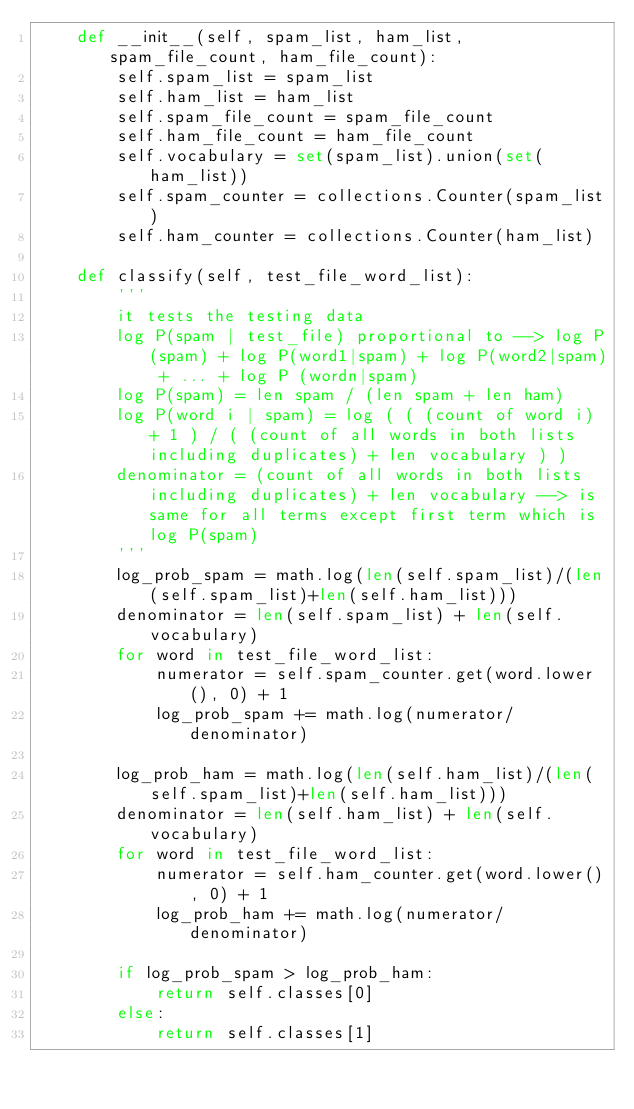Convert code to text. <code><loc_0><loc_0><loc_500><loc_500><_Python_>    def __init__(self, spam_list, ham_list, spam_file_count, ham_file_count):
        self.spam_list = spam_list
        self.ham_list = ham_list
        self.spam_file_count = spam_file_count
        self.ham_file_count = ham_file_count
        self.vocabulary = set(spam_list).union(set(ham_list))
        self.spam_counter = collections.Counter(spam_list)
        self.ham_counter = collections.Counter(ham_list)

    def classify(self, test_file_word_list):
        '''
        it tests the testing data
        log P(spam | test_file) proportional to --> log P(spam) + log P(word1|spam) + log P(word2|spam) + ... + log P (wordn|spam)
        log P(spam) = len spam / (len spam + len ham)
        log P(word i | spam) = log ( ( (count of word i) + 1 ) / ( (count of all words in both lists including duplicates) + len vocabulary ) )
        denominator = (count of all words in both lists including duplicates) + len vocabulary --> is same for all terms except first term which is log P(spam)
        '''
        log_prob_spam = math.log(len(self.spam_list)/(len(self.spam_list)+len(self.ham_list)))
        denominator = len(self.spam_list) + len(self.vocabulary)
        for word in test_file_word_list:
            numerator = self.spam_counter.get(word.lower(), 0) + 1
            log_prob_spam += math.log(numerator/denominator)

        log_prob_ham = math.log(len(self.ham_list)/(len(self.spam_list)+len(self.ham_list)))
        denominator = len(self.ham_list) + len(self.vocabulary)
        for word in test_file_word_list:
            numerator = self.ham_counter.get(word.lower(), 0) + 1
            log_prob_ham += math.log(numerator/denominator)

        if log_prob_spam > log_prob_ham:
            return self.classes[0]
        else:
            return self.classes[1]</code> 